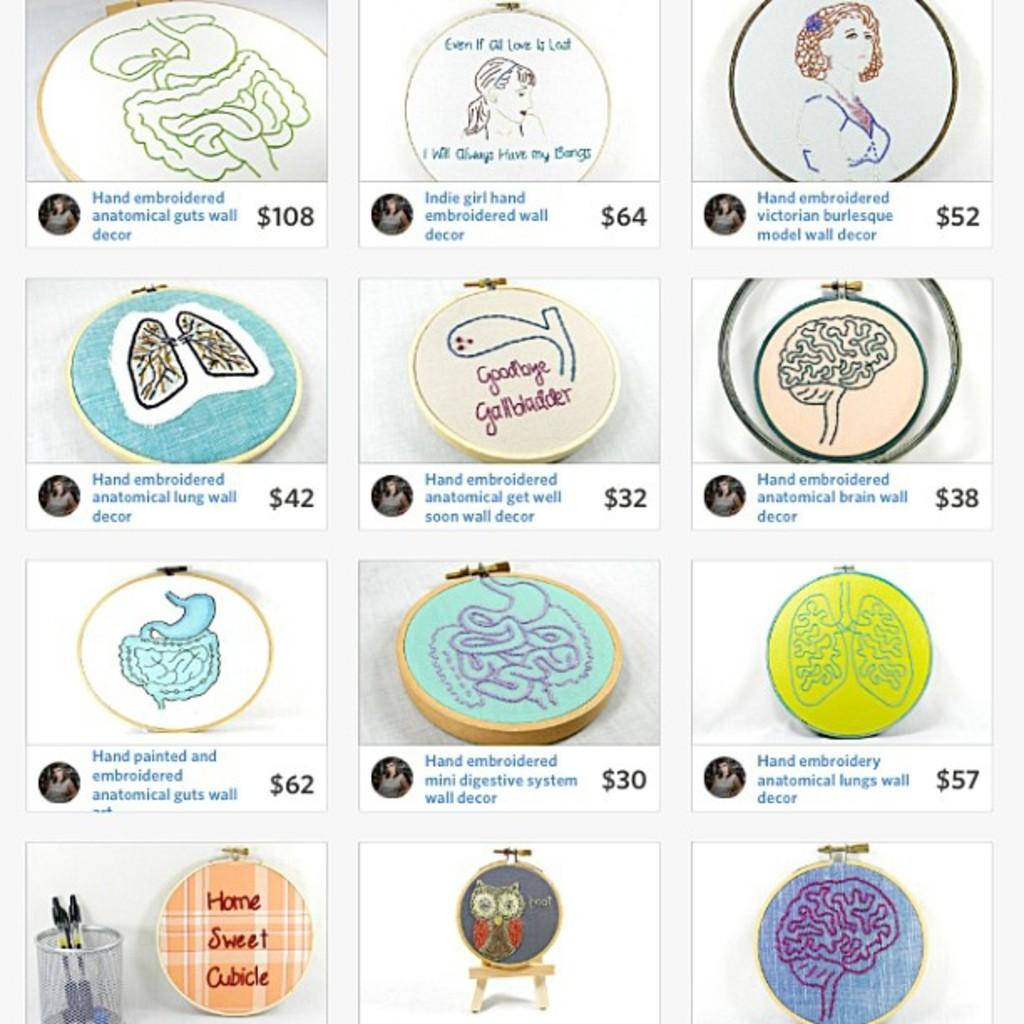What type of drawings are present in the image? The image contains drawings of human body parts. What tools are used for the drawings? There are pens in the image. What surface are the drawings made on? There are boards in the image. What type of bead is used to reason with in the image? There is no bead present in the image, and reasoning is not associated with beads in this context. 